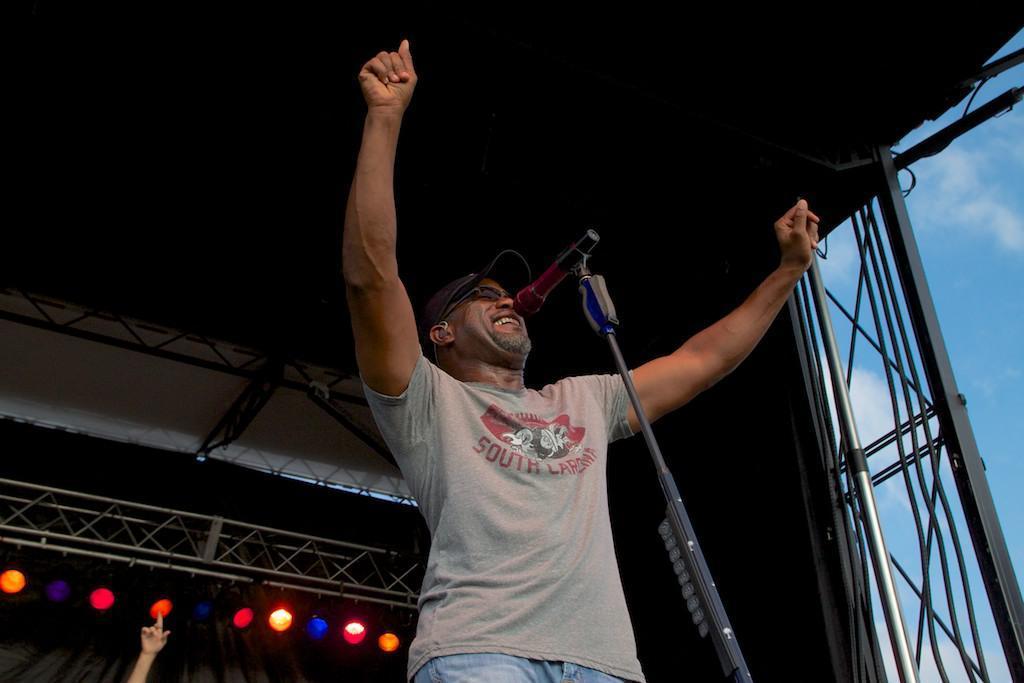Can you describe this image briefly? In this image we can see a person standing on the stage and there is a mic in front of him and in the background, we can see the stage lighting and there is a person's hand. 